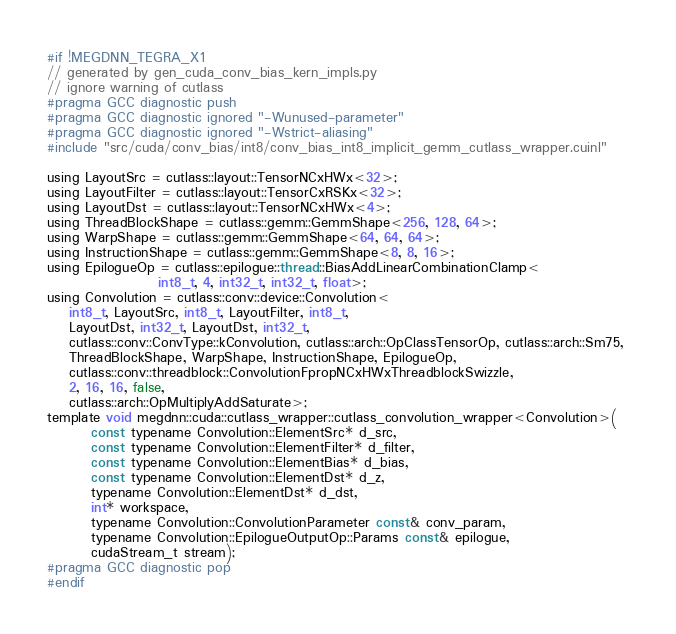Convert code to text. <code><loc_0><loc_0><loc_500><loc_500><_Cuda_>#if !MEGDNN_TEGRA_X1
// generated by gen_cuda_conv_bias_kern_impls.py
// ignore warning of cutlass
#pragma GCC diagnostic push
#pragma GCC diagnostic ignored "-Wunused-parameter"
#pragma GCC diagnostic ignored "-Wstrict-aliasing"
#include "src/cuda/conv_bias/int8/conv_bias_int8_implicit_gemm_cutlass_wrapper.cuinl"

using LayoutSrc = cutlass::layout::TensorNCxHWx<32>;
using LayoutFilter = cutlass::layout::TensorCxRSKx<32>;
using LayoutDst = cutlass::layout::TensorNCxHWx<4>;
using ThreadBlockShape = cutlass::gemm::GemmShape<256, 128, 64>;
using WarpShape = cutlass::gemm::GemmShape<64, 64, 64>;
using InstructionShape = cutlass::gemm::GemmShape<8, 8, 16>;
using EpilogueOp = cutlass::epilogue::thread::BiasAddLinearCombinationClamp<
                    int8_t, 4, int32_t, int32_t, float>;
using Convolution = cutlass::conv::device::Convolution<
    int8_t, LayoutSrc, int8_t, LayoutFilter, int8_t, 
    LayoutDst, int32_t, LayoutDst, int32_t, 
    cutlass::conv::ConvType::kConvolution, cutlass::arch::OpClassTensorOp, cutlass::arch::Sm75, 
    ThreadBlockShape, WarpShape, InstructionShape, EpilogueOp, 
    cutlass::conv::threadblock::ConvolutionFpropNCxHWxThreadblockSwizzle, 
    2, 16, 16, false, 
    cutlass::arch::OpMultiplyAddSaturate>;
template void megdnn::cuda::cutlass_wrapper::cutlass_convolution_wrapper<Convolution>(
        const typename Convolution::ElementSrc* d_src, 
        const typename Convolution::ElementFilter* d_filter, 
        const typename Convolution::ElementBias* d_bias, 
        const typename Convolution::ElementDst* d_z, 
        typename Convolution::ElementDst* d_dst, 
        int* workspace, 
        typename Convolution::ConvolutionParameter const& conv_param, 
        typename Convolution::EpilogueOutputOp::Params const& epilogue, 
        cudaStream_t stream);
#pragma GCC diagnostic pop
#endif
</code> 